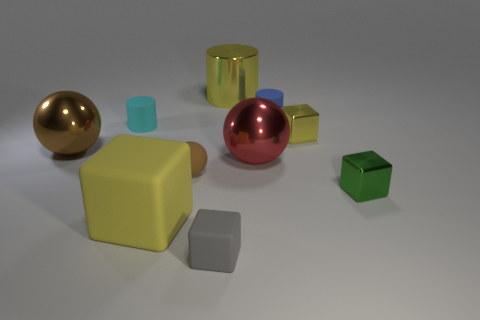There is a small object that is the same shape as the large red metal thing; what is its material?
Keep it short and to the point. Rubber. What material is the tiny cyan thing?
Your response must be concise. Rubber. How many large shiny spheres are on the left side of the large yellow metallic thing?
Keep it short and to the point. 1. Does the metallic sphere right of the brown shiny object have the same size as the ball on the left side of the small brown thing?
Your answer should be very brief. Yes. How many other objects are the same size as the brown rubber thing?
Offer a very short reply. 5. There is a yellow block that is on the left side of the yellow block behind the brown metal thing that is on the left side of the gray object; what is it made of?
Offer a terse response. Rubber. There is a red metal thing; is its size the same as the rubber block that is to the right of the tiny matte ball?
Provide a succinct answer. No. What is the size of the ball that is on the left side of the tiny gray block and behind the brown rubber object?
Your answer should be compact. Large. Are there any other shiny balls that have the same color as the small ball?
Make the answer very short. Yes. There is a shiny cube that is in front of the small sphere that is in front of the cyan matte thing; what is its color?
Make the answer very short. Green. 